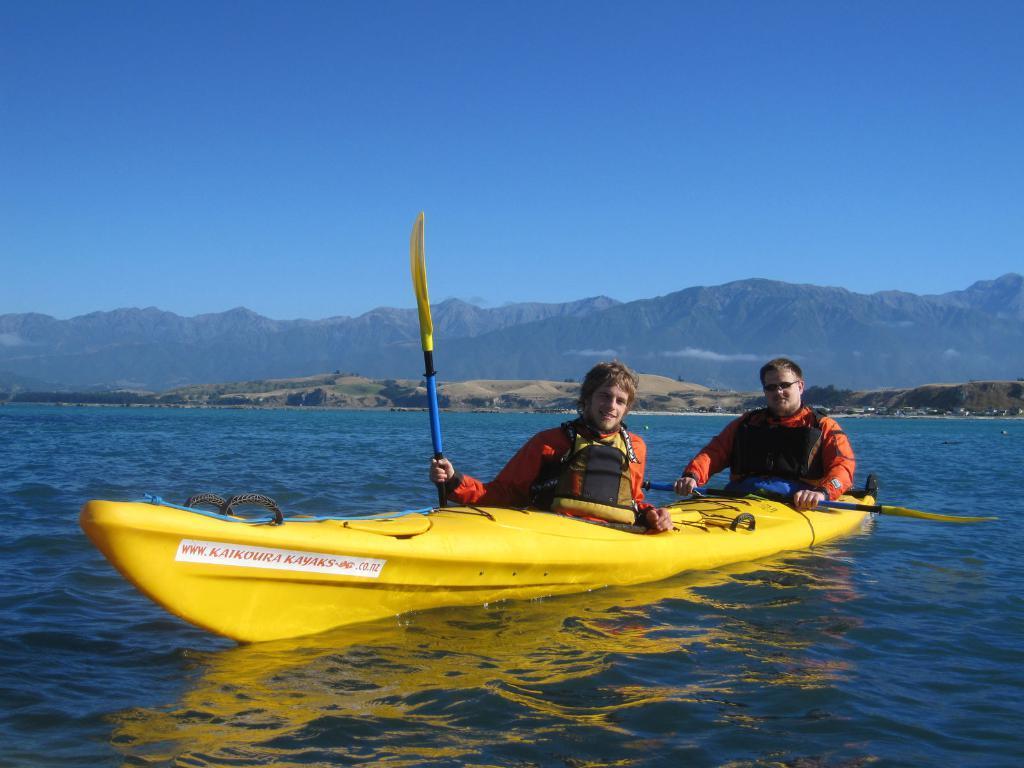How would you summarize this image in a sentence or two? In this image we can see men sitting on the kayak boat and holding rows in their hands. In the background we can see hills, mountains and sky. 